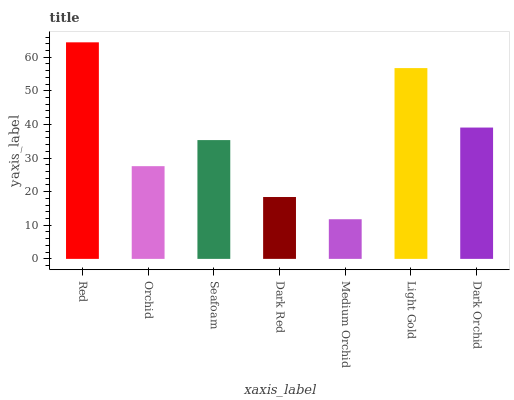Is Medium Orchid the minimum?
Answer yes or no. Yes. Is Red the maximum?
Answer yes or no. Yes. Is Orchid the minimum?
Answer yes or no. No. Is Orchid the maximum?
Answer yes or no. No. Is Red greater than Orchid?
Answer yes or no. Yes. Is Orchid less than Red?
Answer yes or no. Yes. Is Orchid greater than Red?
Answer yes or no. No. Is Red less than Orchid?
Answer yes or no. No. Is Seafoam the high median?
Answer yes or no. Yes. Is Seafoam the low median?
Answer yes or no. Yes. Is Light Gold the high median?
Answer yes or no. No. Is Medium Orchid the low median?
Answer yes or no. No. 